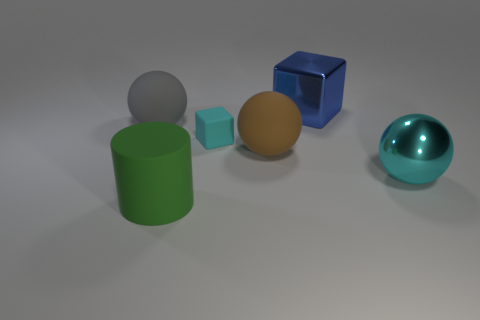What shape is the cyan thing that is behind the ball that is to the right of the blue metallic thing?
Give a very brief answer. Cube. What size is the cube that is the same color as the shiny ball?
Offer a very short reply. Small. There is a cyan thing that is left of the large brown rubber sphere; does it have the same shape as the cyan shiny thing?
Your answer should be very brief. No. Are there more blue blocks that are behind the cyan cube than big spheres to the right of the blue shiny cube?
Your answer should be very brief. No. How many metal things are in front of the cyan thing that is behind the brown ball?
Keep it short and to the point. 1. There is a big thing that is the same color as the matte block; what material is it?
Ensure brevity in your answer.  Metal. How many other things are the same color as the big cylinder?
Keep it short and to the point. 0. There is a large metal thing to the left of the ball that is in front of the brown thing; what color is it?
Provide a short and direct response. Blue. Are there any tiny shiny balls that have the same color as the matte cube?
Keep it short and to the point. No. How many rubber objects are large purple cylinders or gray balls?
Make the answer very short. 1. 